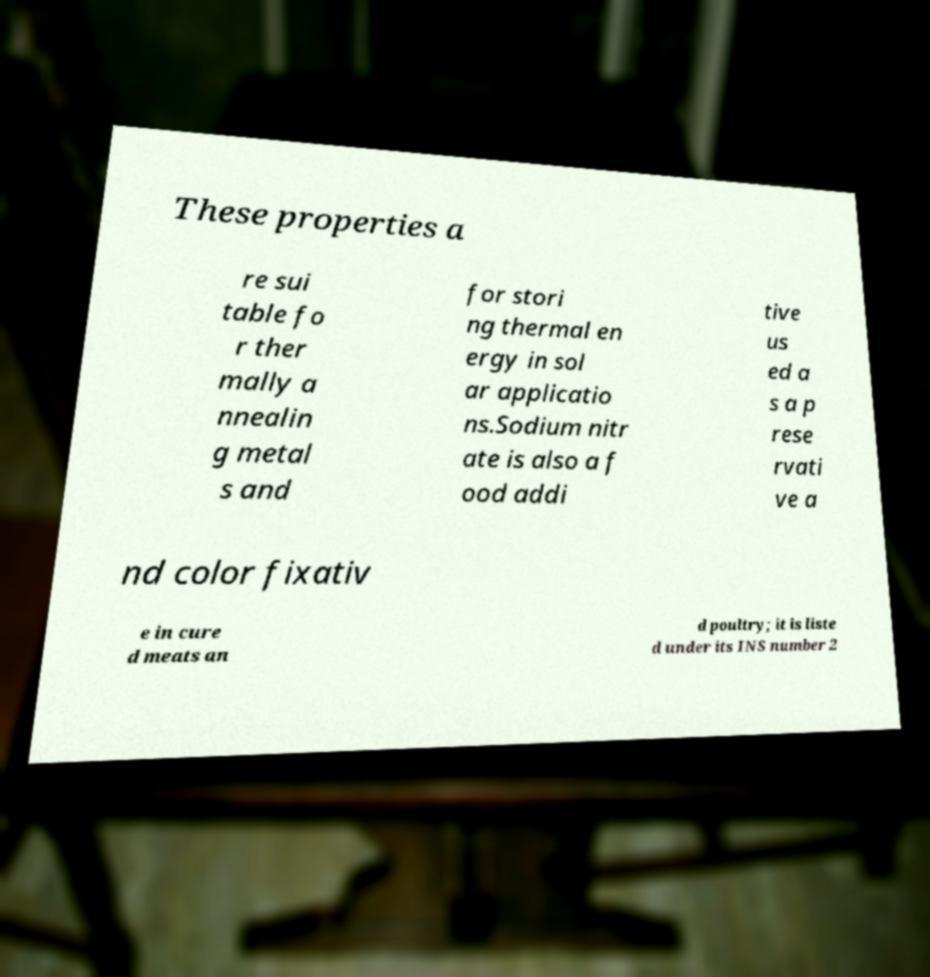Could you assist in decoding the text presented in this image and type it out clearly? These properties a re sui table fo r ther mally a nnealin g metal s and for stori ng thermal en ergy in sol ar applicatio ns.Sodium nitr ate is also a f ood addi tive us ed a s a p rese rvati ve a nd color fixativ e in cure d meats an d poultry; it is liste d under its INS number 2 